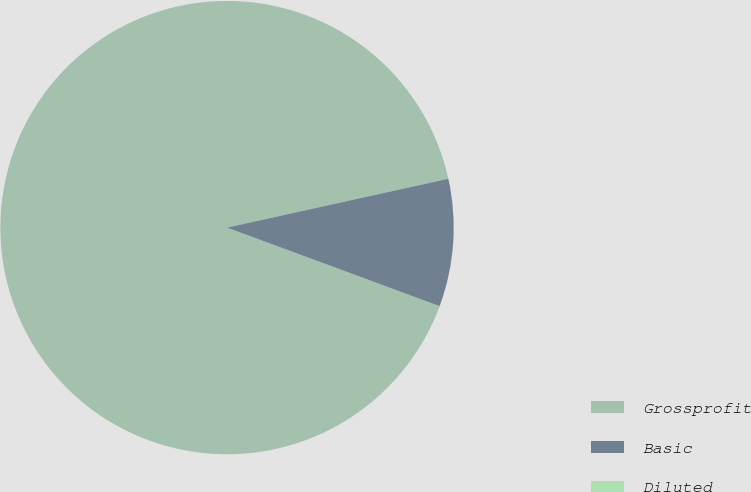<chart> <loc_0><loc_0><loc_500><loc_500><pie_chart><fcel>Grossprofit<fcel>Basic<fcel>Diluted<nl><fcel>90.91%<fcel>9.09%<fcel>0.0%<nl></chart> 